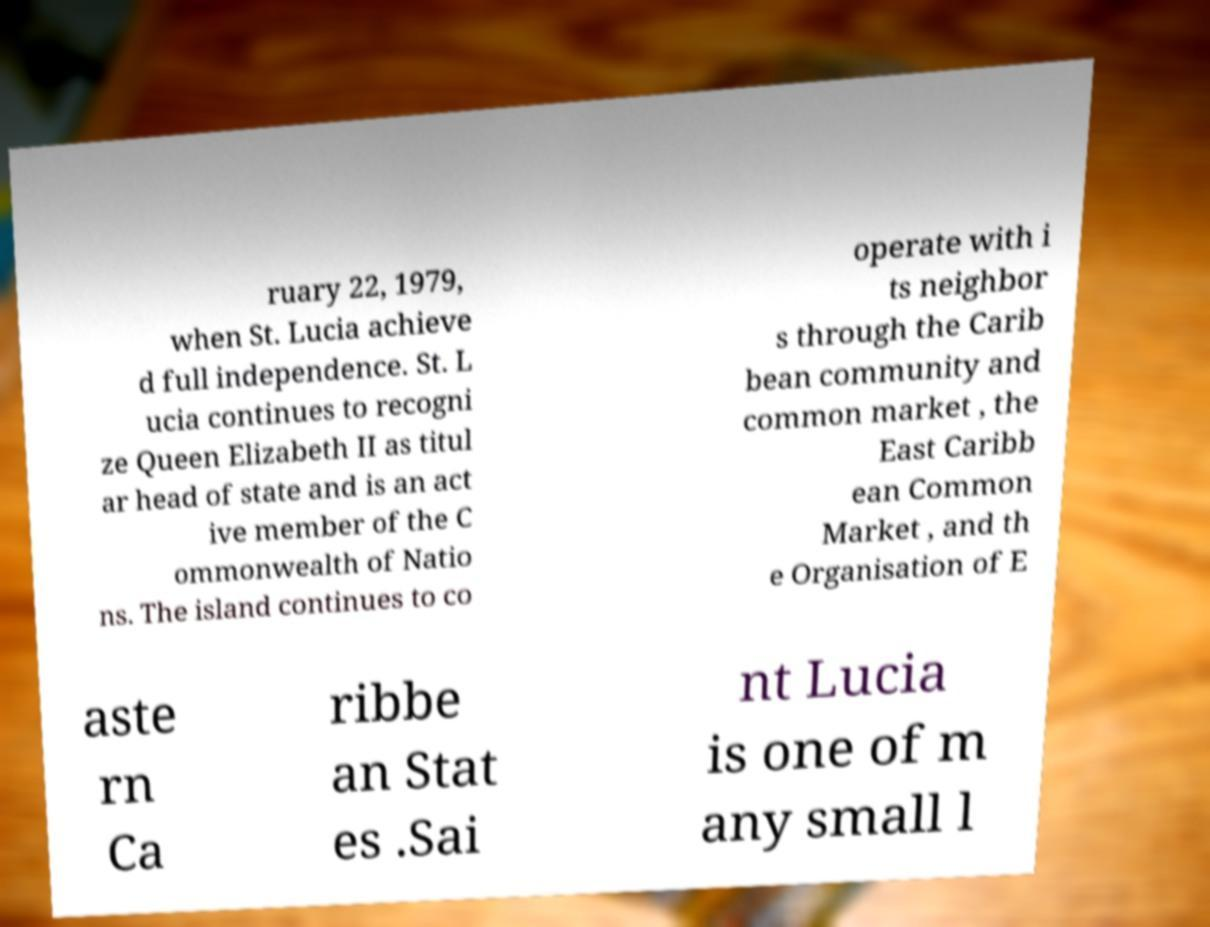Can you read and provide the text displayed in the image?This photo seems to have some interesting text. Can you extract and type it out for me? ruary 22, 1979, when St. Lucia achieve d full independence. St. L ucia continues to recogni ze Queen Elizabeth II as titul ar head of state and is an act ive member of the C ommonwealth of Natio ns. The island continues to co operate with i ts neighbor s through the Carib bean community and common market , the East Caribb ean Common Market , and th e Organisation of E aste rn Ca ribbe an Stat es .Sai nt Lucia is one of m any small l 